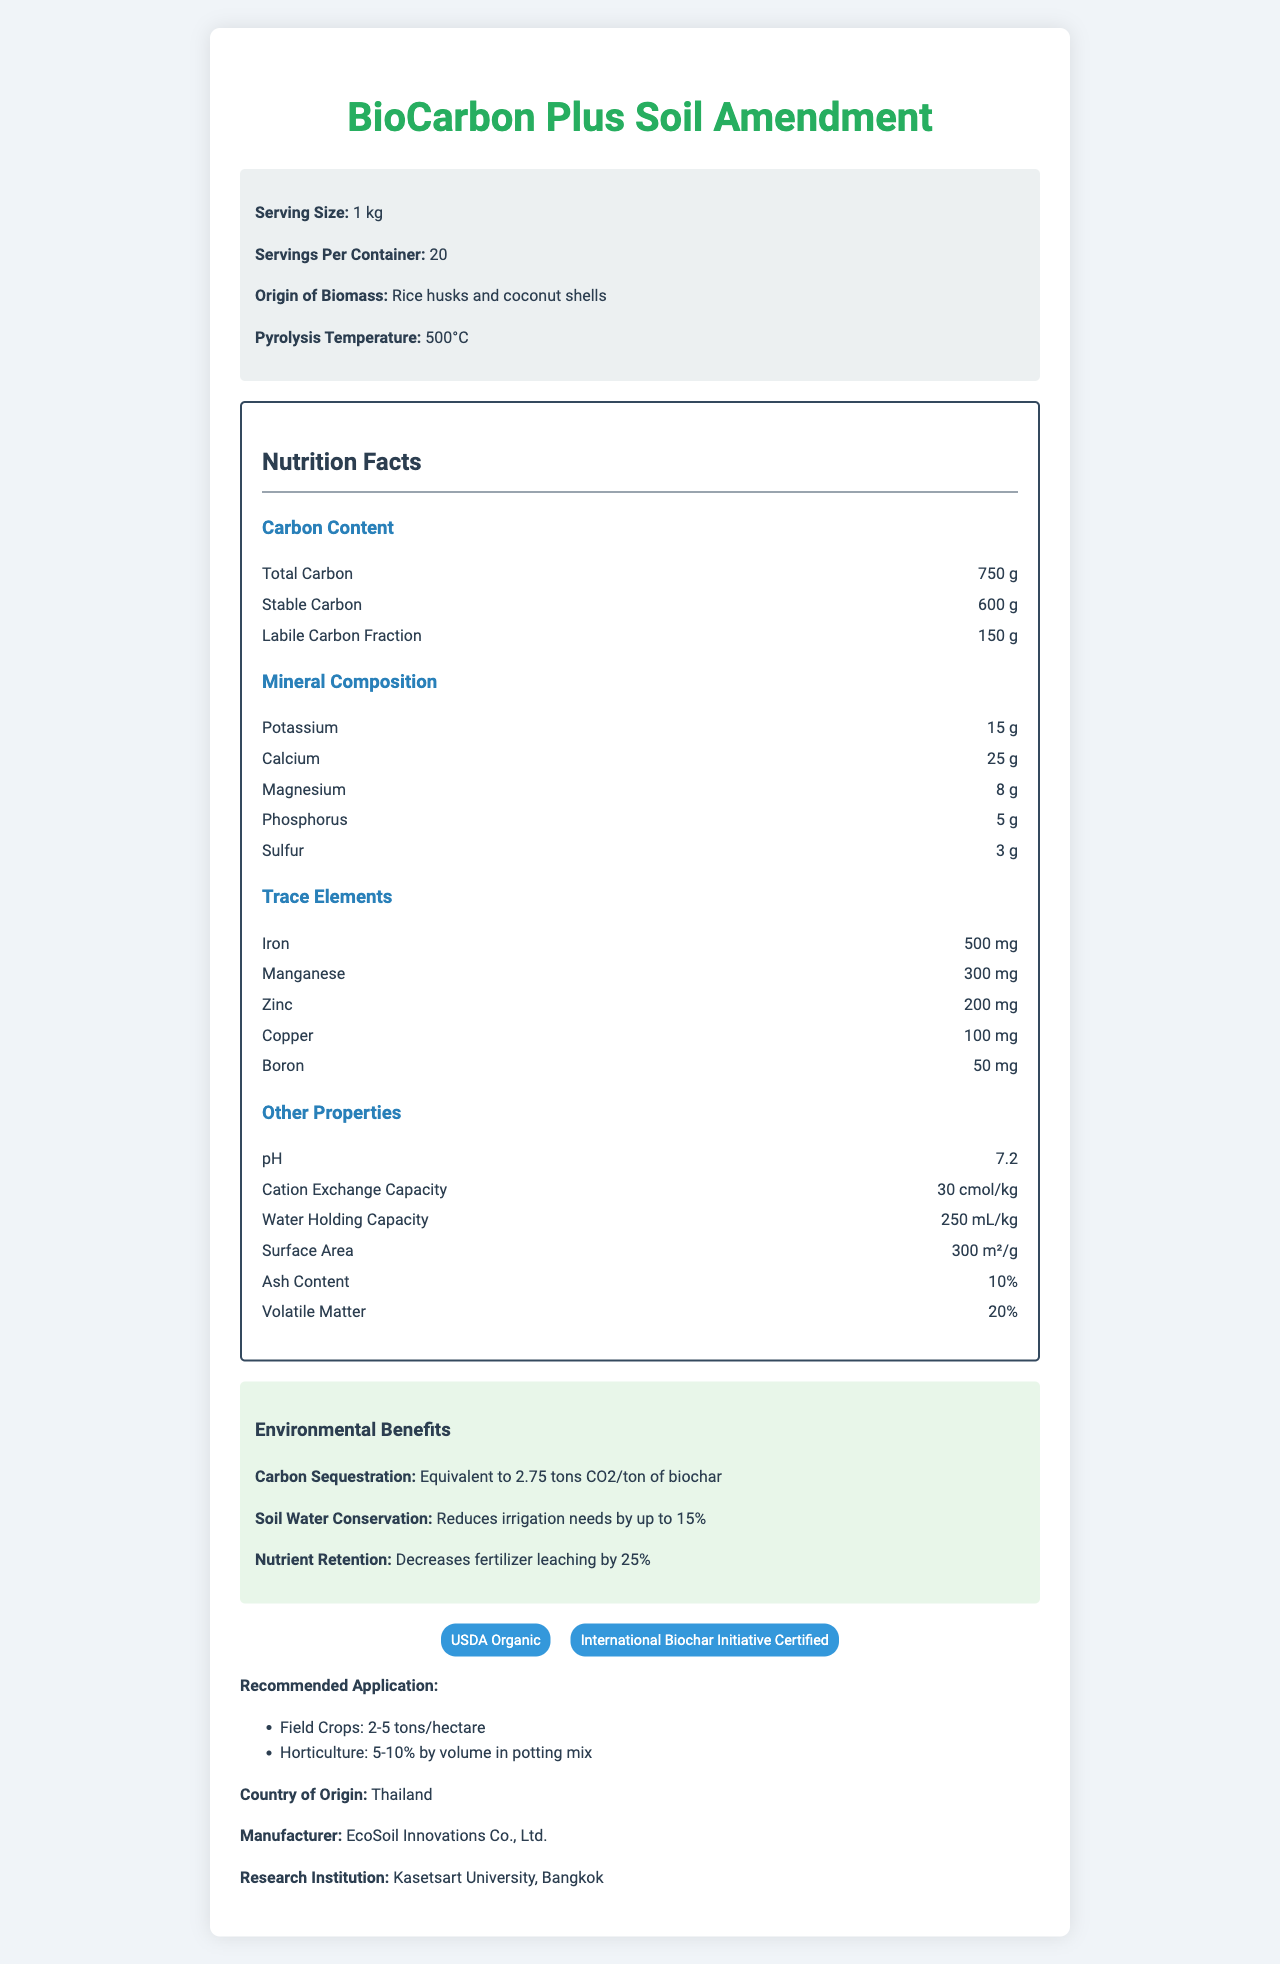what is the serving size? The serving size is directly listed as "1 kg" in the "product-info" section of the document.
Answer: 1 kg how much stable carbon is present per serving? The stable carbon content is specified as "600 g" under the "Carbon Content" section of the nutrition label.
Answer: 600 g what is the surface area of BioCarbon Plus per gram? The surface area is indicated as "300 m²/g" under the "Other Properties" section of the nutrition label.
Answer: 300 m²/g what is the pH level of the BioCarbon Plus Soil Amendment? The pH level is mentioned as "7.2" under the "Other Properties" section of the nutrition label.
Answer: 7.2 which minerals are included in the mineral composition? The mineral composition section lists the minerals potassium, calcium, magnesium, phosphorus, and sulfur.
Answer: Potassium, Calcium, Magnesium, Phosphorus, Sulfur how many servings are there per container? The document states "Servings Per Container: 20" in the "product-info" section.
Answer: 20 who is the manufacturer of BioCarbon Plus? The manufacturer information is given as "EcoSoil Innovations Co., Ltd." near the bottom of the document.
Answer: EcoSoil Innovations Co., Ltd. what is the cation exchange capacity? A. 20 cmol/kg B. 25 cmol/kg C. 30 cmol/kg The cation exchange capacity is stated as "30 cmol/kg" under the "Other Properties" section.
Answer: C. 30 cmol/kg which trace element is present in the highest amount? A. Iron B. Manganese C. Zinc D. Copper Iron is present in the highest amount, listed as "500 mg" under the "Trace Elements" section, which is the highest value among the listed elements.
Answer: A. Iron what is the origin of the biomass? A. Corn stalks B. Rice husks and coconut shells C. Bamboo D. Mixed wood chips The origin of the biomass is mentioned as "Rice husks and coconut shells" in the "product-info" section.
Answer: B. Rice husks and coconut shells is the soil amendment certified by the USDA? The certifications section lists "USDA Organic," confirming it is certified by the USDA.
Answer: Yes describe the environmental benefits of BioCarbon Plus The document outlines these benefits in the "Environmental Benefits" section, highlighting its positive impact on the environment.
Answer: BioCarbon Plus provides multiple environmental benefits, including carbon sequestration equivalent to 2.75 tons CO2 per ton of biochar, reducing irrigation needs by up to 15%, and decreasing fertilizer leaching by 25%. what is the maximum recommended application rate for field crops? The recommended application for field crops is listed as "2-5 tons/hectare" under the "Recommended Application" section, with 5 tons/hectare being the maximum rate.
Answer: 5 tons/hectare is the recommendation for horticulture 5-10% by volume in potting mix? The recommended application section for horticulture specifies "5-10% by volume in potting mix," confirming the information.
Answer: Yes where is the research institution located? While the document states the research institution as "Kasetsart University, Bangkok," it does not provide the exact details about its location.
Answer: I don't know summarize the main features of the BioCarbon Plus Soil Amendment The summary combines information from several sections, including the product description, carbon content, mineral composition, certifications, environmental benefits, and recommended applications.
Answer: BioCarbon Plus is a biochar-based soil amendment derived from rice husks and coconut shells, produced at 500°C. It has a high carbon content with 750 g of total carbon per kg, including 600 g of stable carbon. It also contains key minerals and trace elements. The product is certified USDA Organic and offers environmental benefits such as carbon sequestration, water conservation, and nutrient retention. It is recommended for use at 2-5 tons/hectare for field crops and 5-10% by volume in potting mix for horticulture. 